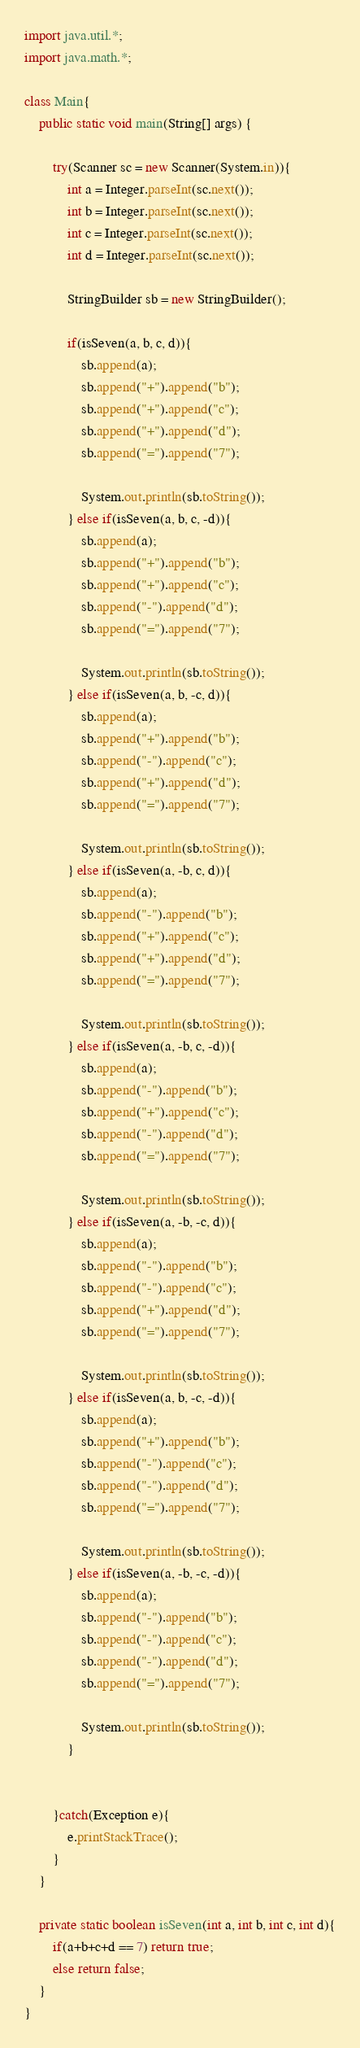<code> <loc_0><loc_0><loc_500><loc_500><_Java_>import java.util.*;
import java.math.*;
     
class Main{
    public static void main(String[] args) {
        
        try(Scanner sc = new Scanner(System.in)){
            int a = Integer.parseInt(sc.next());
            int b = Integer.parseInt(sc.next());
            int c = Integer.parseInt(sc.next());
            int d = Integer.parseInt(sc.next());

            StringBuilder sb = new StringBuilder();

            if(isSeven(a, b, c, d)){
                sb.append(a);
                sb.append("+").append("b");
                sb.append("+").append("c");
                sb.append("+").append("d");
                sb.append("=").append("7");
                
                System.out.println(sb.toString());
            } else if(isSeven(a, b, c, -d)){
                sb.append(a);
                sb.append("+").append("b");
                sb.append("+").append("c");
                sb.append("-").append("d");
                sb.append("=").append("7");
                
                System.out.println(sb.toString());
            } else if(isSeven(a, b, -c, d)){
                sb.append(a);
                sb.append("+").append("b");
                sb.append("-").append("c");
                sb.append("+").append("d");
                sb.append("=").append("7");
                
                System.out.println(sb.toString());
            } else if(isSeven(a, -b, c, d)){
                sb.append(a);
                sb.append("-").append("b");
                sb.append("+").append("c");
                sb.append("+").append("d");
                sb.append("=").append("7");
                
                System.out.println(sb.toString());
            } else if(isSeven(a, -b, c, -d)){
                sb.append(a);
                sb.append("-").append("b");
                sb.append("+").append("c");
                sb.append("-").append("d");
                sb.append("=").append("7");
                
                System.out.println(sb.toString());
            } else if(isSeven(a, -b, -c, d)){
                sb.append(a);
                sb.append("-").append("b");
                sb.append("-").append("c");
                sb.append("+").append("d");
                sb.append("=").append("7");
                
                System.out.println(sb.toString());
            } else if(isSeven(a, b, -c, -d)){
                sb.append(a);
                sb.append("+").append("b");
                sb.append("-").append("c");
                sb.append("-").append("d");
                sb.append("=").append("7");
                
                System.out.println(sb.toString());
            } else if(isSeven(a, -b, -c, -d)){
                sb.append(a);
                sb.append("-").append("b");
                sb.append("-").append("c");
                sb.append("-").append("d");
                sb.append("=").append("7");
                
                System.out.println(sb.toString());
            }
            

        }catch(Exception e){
            e.printStackTrace();
        }        
    }

    private static boolean isSeven(int a, int b, int c, int d){
        if(a+b+c+d == 7) return true;
        else return false;
    }
}</code> 